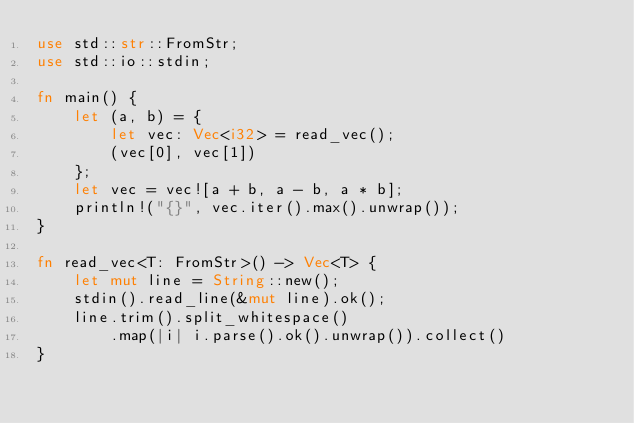<code> <loc_0><loc_0><loc_500><loc_500><_Rust_>use std::str::FromStr;
use std::io::stdin;

fn main() {
    let (a, b) = {
        let vec: Vec<i32> = read_vec();
        (vec[0], vec[1])
    };
    let vec = vec![a + b, a - b, a * b];
    println!("{}", vec.iter().max().unwrap());
}

fn read_vec<T: FromStr>() -> Vec<T> {
    let mut line = String::new();
    stdin().read_line(&mut line).ok();
    line.trim().split_whitespace()
        .map(|i| i.parse().ok().unwrap()).collect()
}</code> 